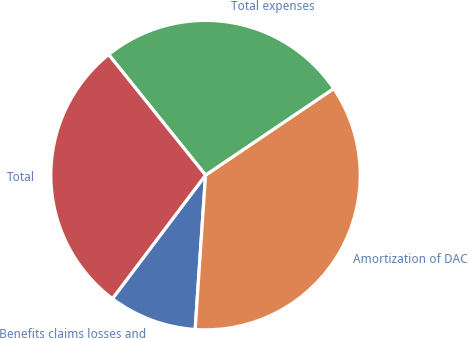Convert chart to OTSL. <chart><loc_0><loc_0><loc_500><loc_500><pie_chart><fcel>Benefits claims losses and<fcel>Amortization of DAC<fcel>Total expenses<fcel>Total<nl><fcel>9.21%<fcel>35.53%<fcel>26.32%<fcel>28.95%<nl></chart> 